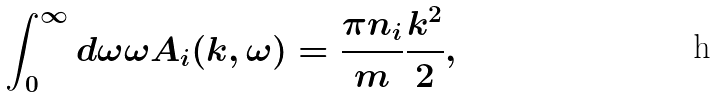Convert formula to latex. <formula><loc_0><loc_0><loc_500><loc_500>\int _ { 0 } ^ { \infty } d \omega \omega A _ { i } ( k , \omega ) = \frac { \pi n _ { i } } { m } \frac { k ^ { 2 } } { 2 } ,</formula> 